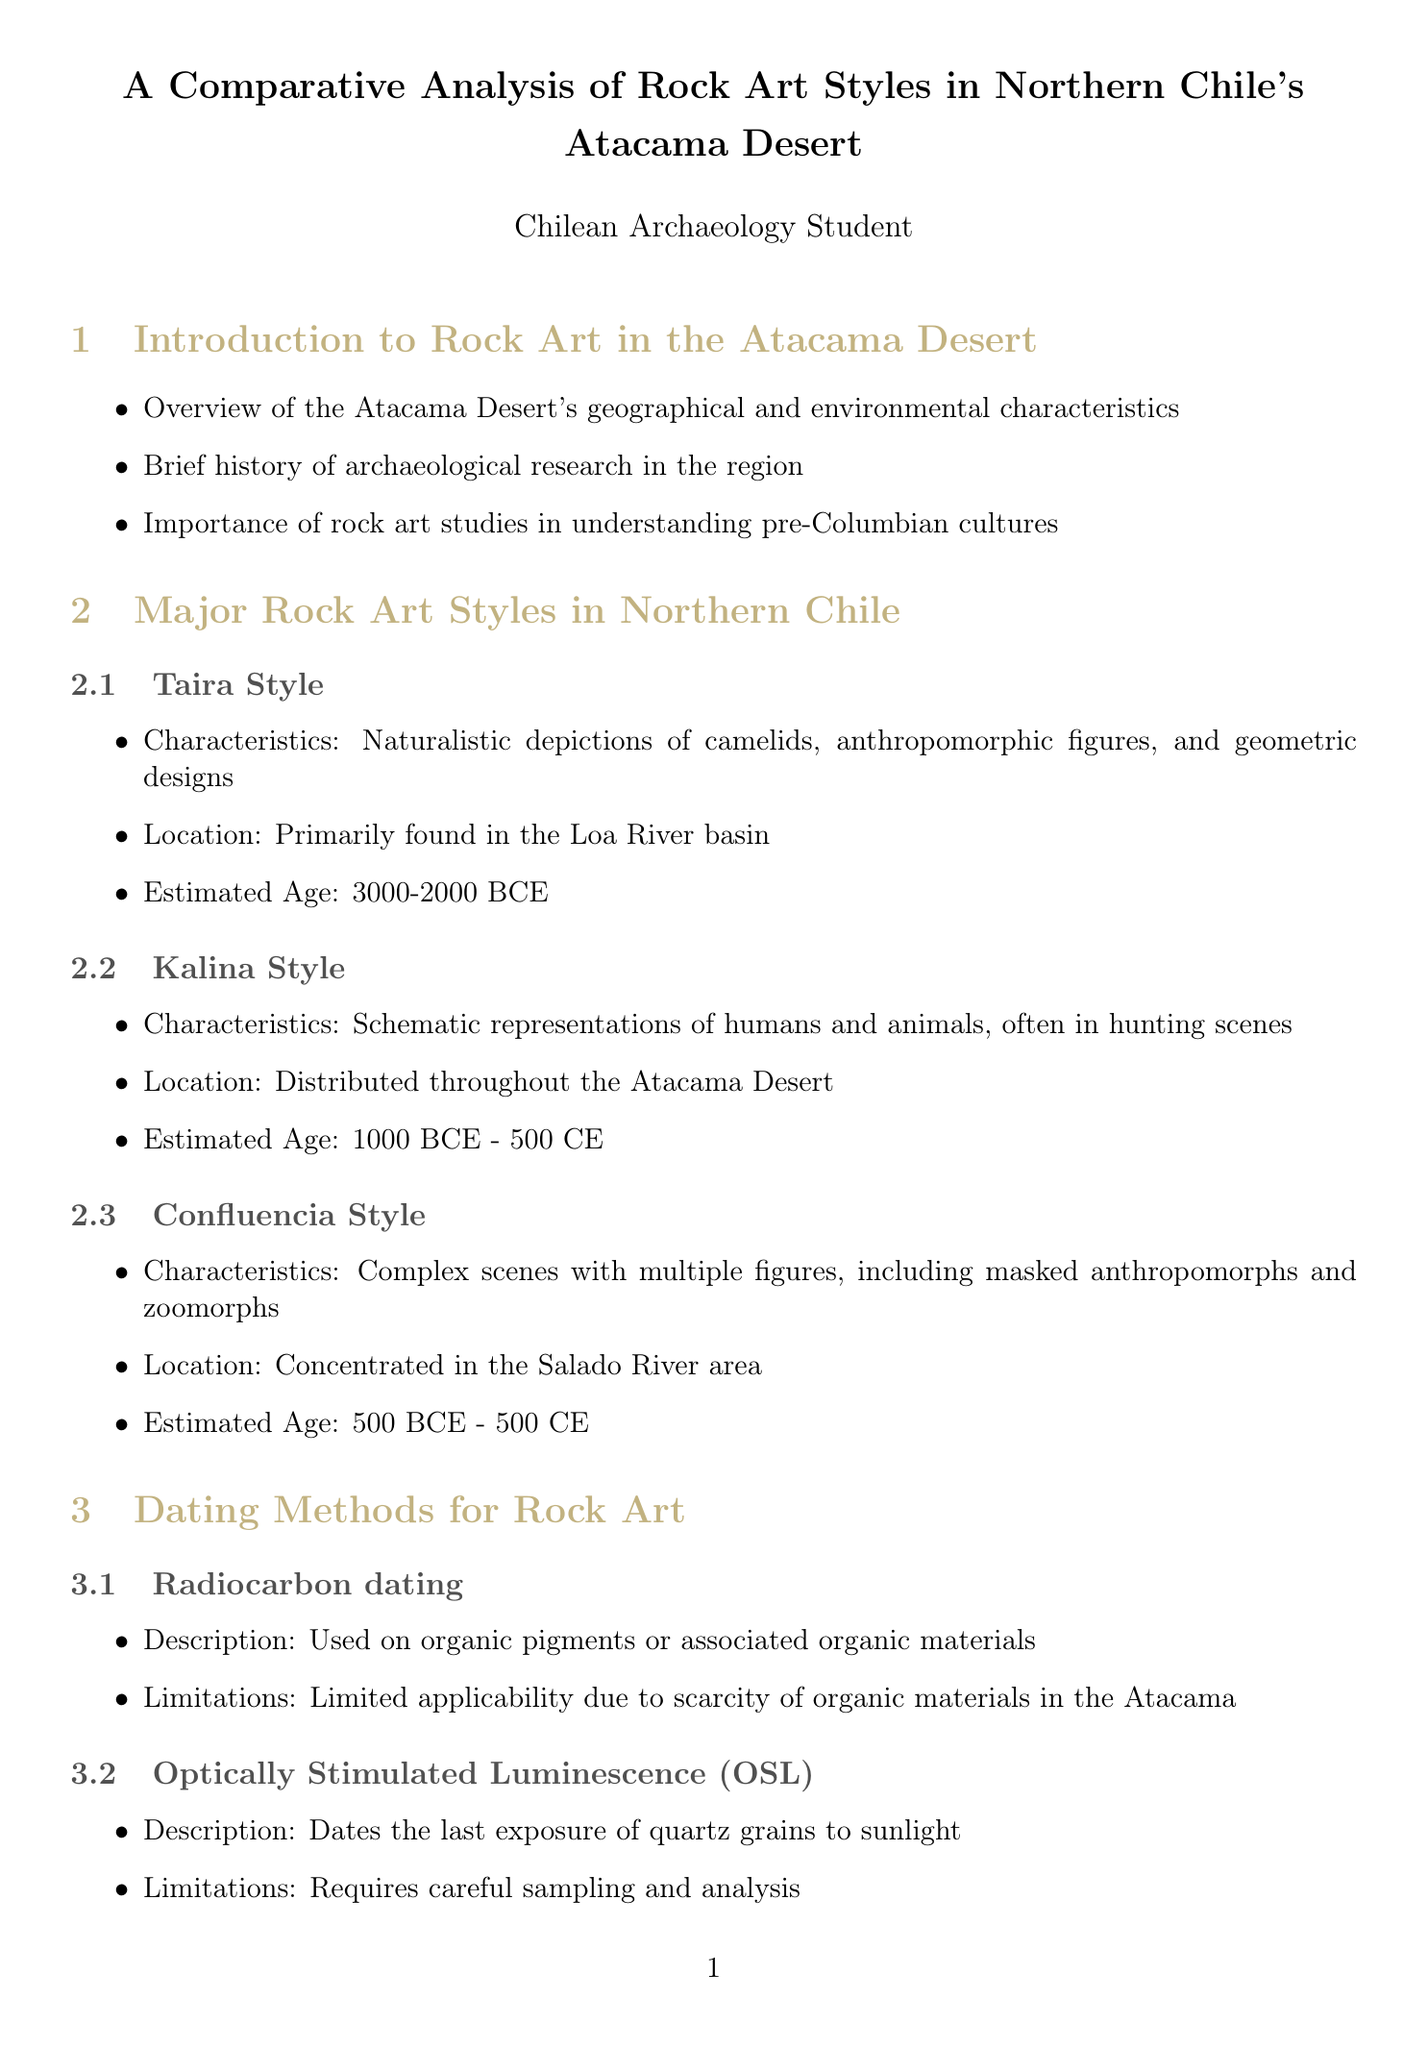What are the key features of Valle de Lluta? The key features include a large concentration of geoglyphs and petroglyphs, providing insights into Tiwanaku influence in the region.
Answer: Large concentration of geoglyphs and petroglyphs What is the estimated age of the Kalina Style? The estimated age of Kalina Style rock art is provided in the document as being from 1000 BCE to 500 CE.
Answer: 1000 BCE - 500 CE What dating method uses organic materials? The dating method described in the document that uses organic materials is Radiocarbon dating.
Answer: Radiocarbon dating Who conducted extensive research on the rock art in the Loa River basin? The document mentions Dr. José Berenguer as the one who conducted extensive research on rock art in the Loa River basin.
Answer: Dr. José Berenguer What significant threat to rock art preservation is mentioned in the document? The document identifies mining activities as a significant threat to rock art preservation in the Atacama Desert.
Answer: Mining activities What is the Taira Style characterized by? The Taira Style is characterized by naturalistic depictions of camelids, anthropomorphic figures, and geometric designs.
Answer: Naturalistic depictions of camelids, anthropomorphic figures, and geometric designs What cultural aspect is evidenced by rock art according to the document? The document indicates that rock art provides evidence of social structures and belief systems within ancient cultures.
Answer: Social structures and belief systems What type of analysis is less precise than absolute dating methods? Relative dating techniques are mentioned in the document as being less precise than absolute dating methods.
Answer: Relative dating techniques 